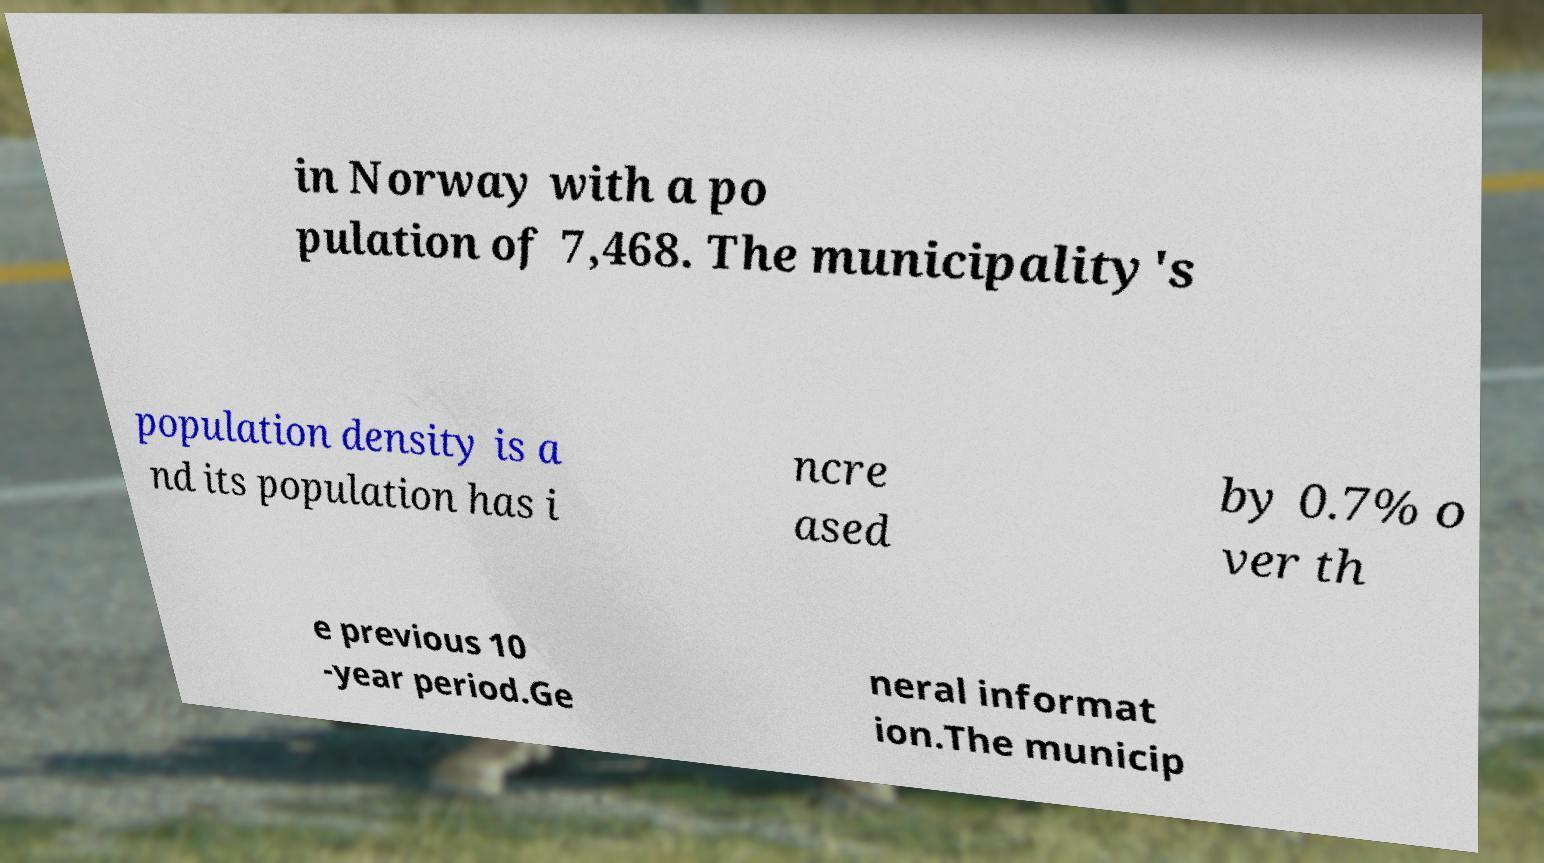Can you accurately transcribe the text from the provided image for me? in Norway with a po pulation of 7,468. The municipality's population density is a nd its population has i ncre ased by 0.7% o ver th e previous 10 -year period.Ge neral informat ion.The municip 